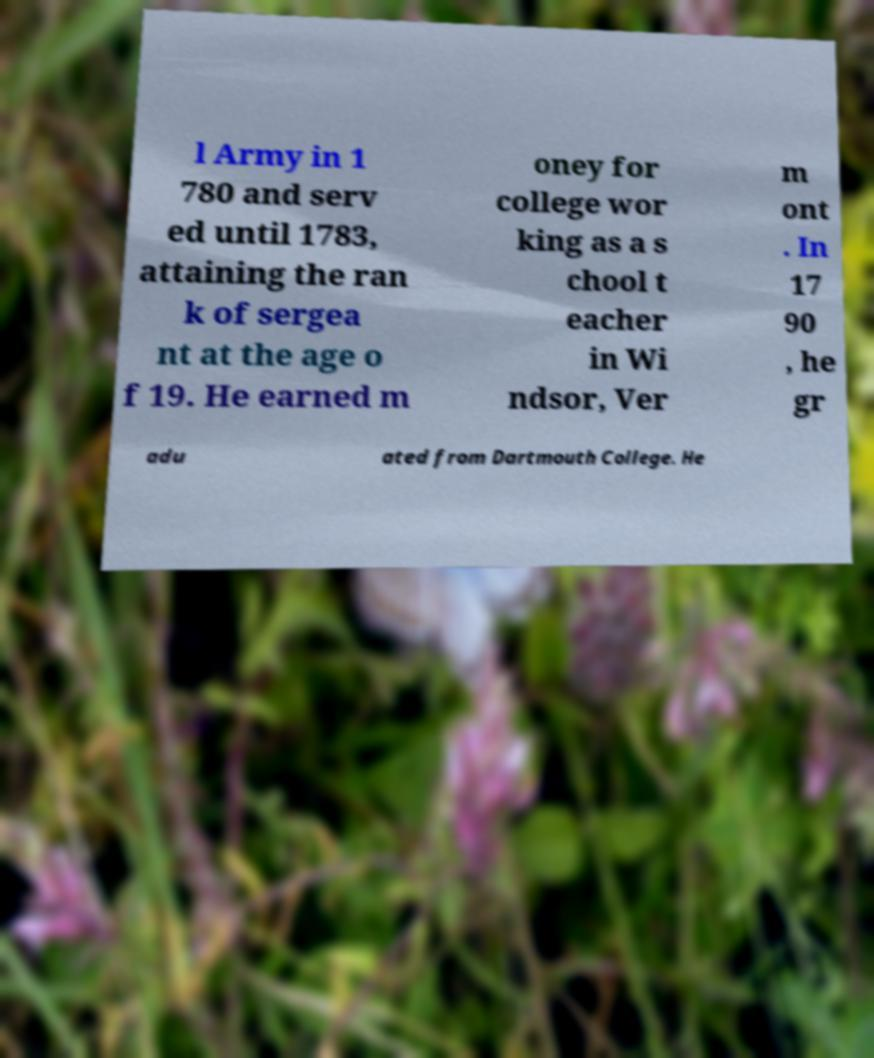What messages or text are displayed in this image? I need them in a readable, typed format. l Army in 1 780 and serv ed until 1783, attaining the ran k of sergea nt at the age o f 19. He earned m oney for college wor king as a s chool t eacher in Wi ndsor, Ver m ont . In 17 90 , he gr adu ated from Dartmouth College. He 